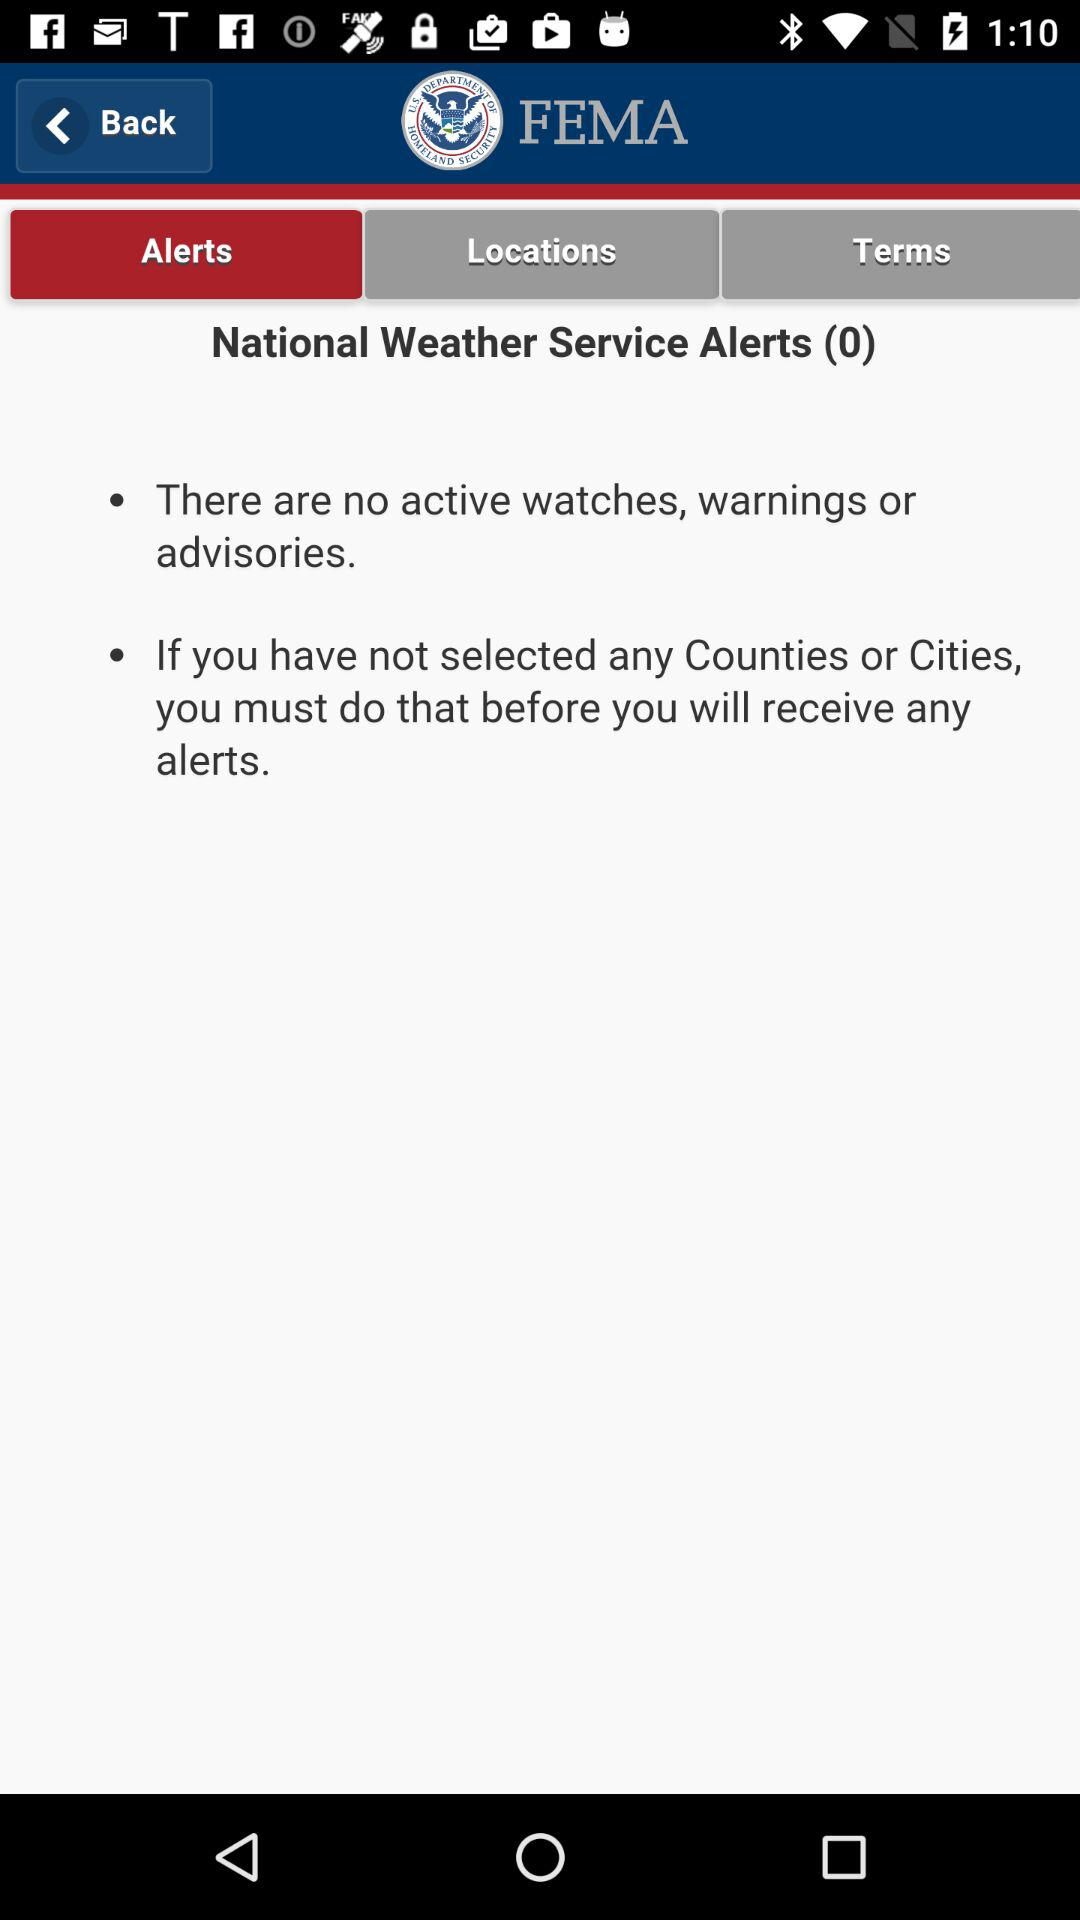How many active watches, warnings, or advisories are there?
Answer the question using a single word or phrase. 0 